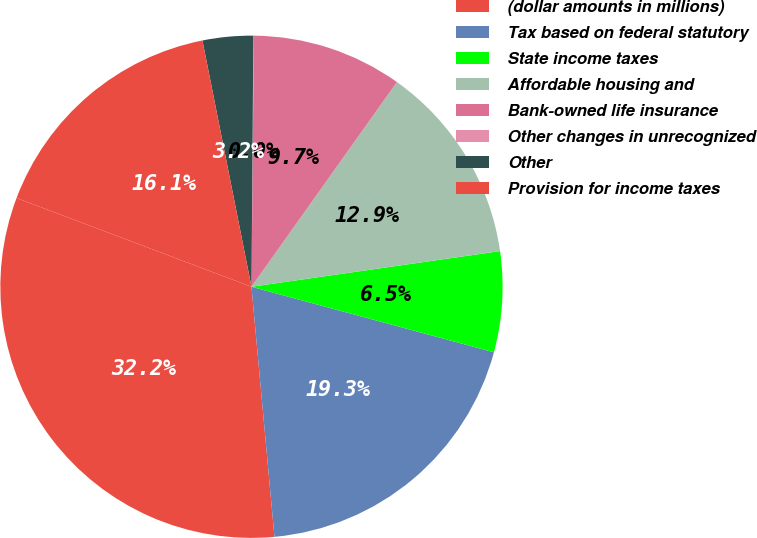Convert chart. <chart><loc_0><loc_0><loc_500><loc_500><pie_chart><fcel>(dollar amounts in millions)<fcel>Tax based on federal statutory<fcel>State income taxes<fcel>Affordable housing and<fcel>Bank-owned life insurance<fcel>Other changes in unrecognized<fcel>Other<fcel>Provision for income taxes<nl><fcel>32.21%<fcel>19.34%<fcel>6.47%<fcel>12.9%<fcel>9.68%<fcel>0.03%<fcel>3.25%<fcel>16.12%<nl></chart> 